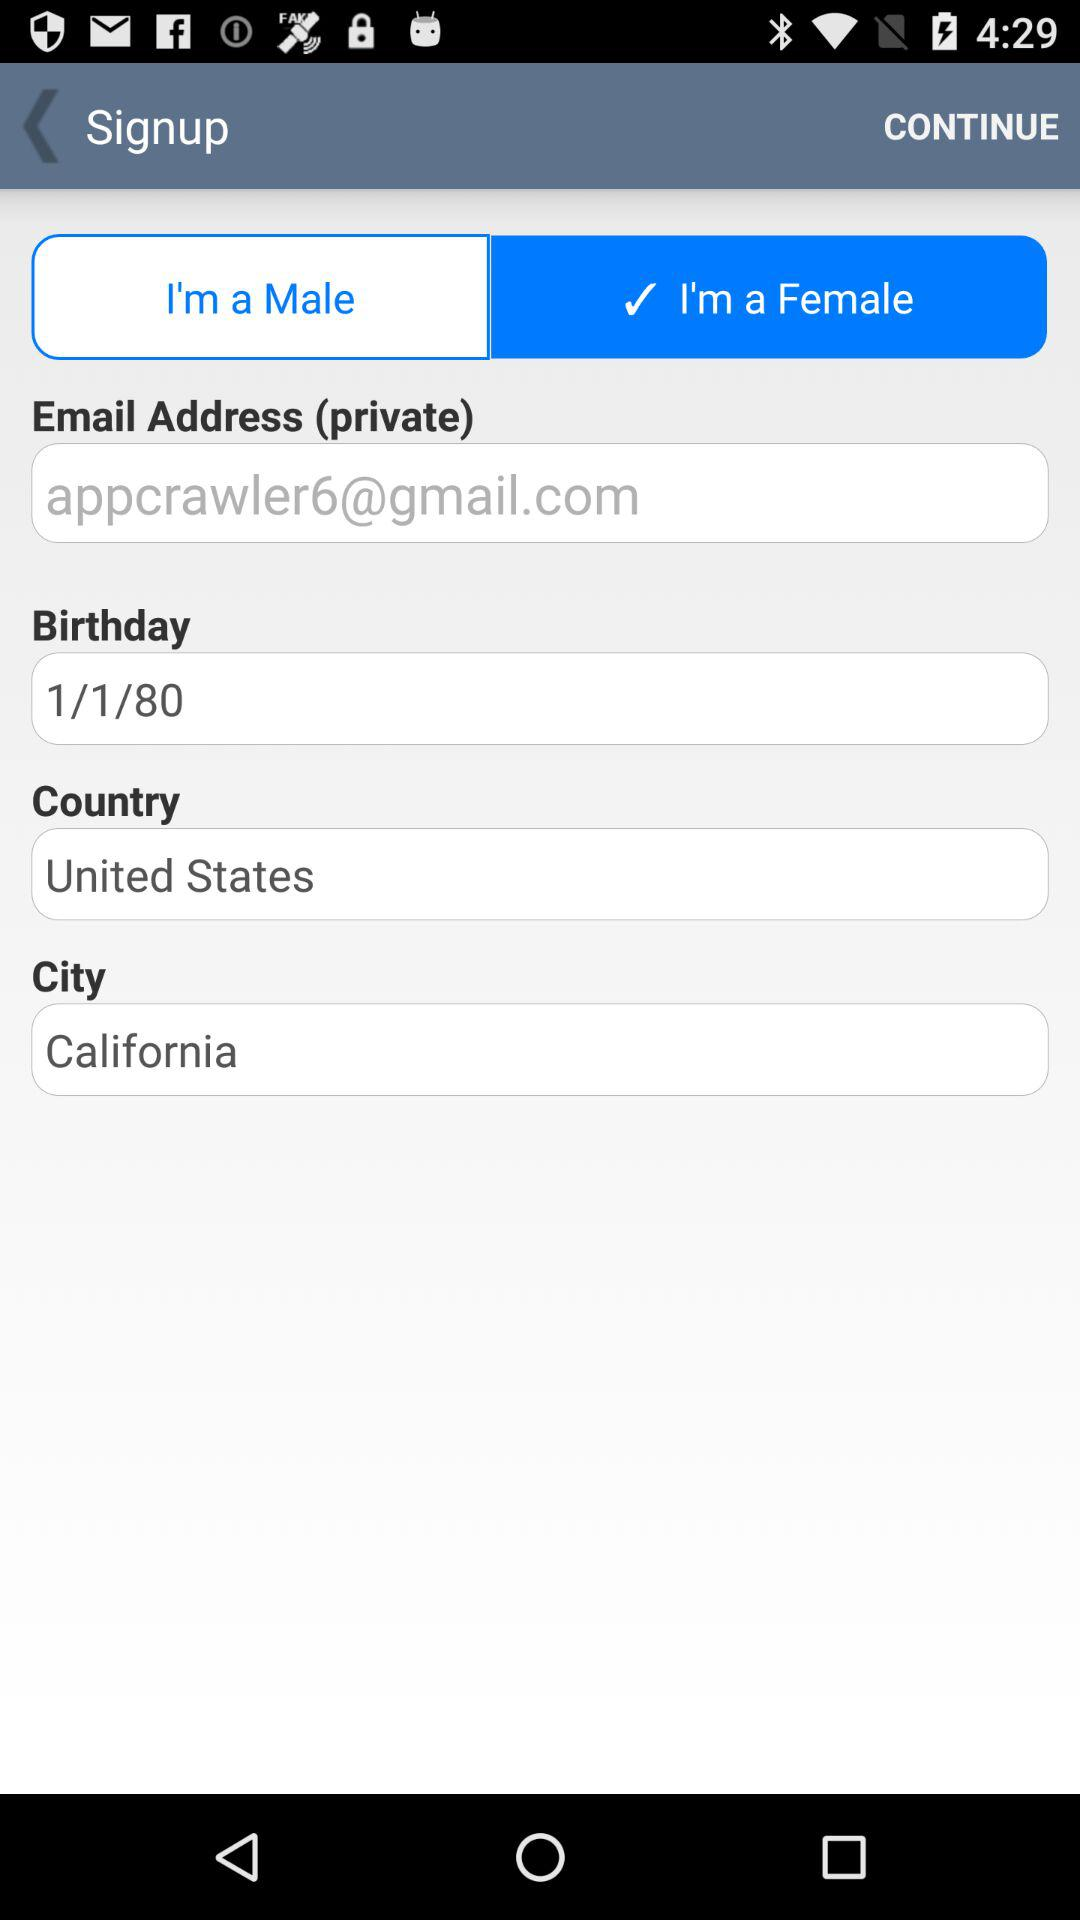Which gender is selected? The selected gender is female. 